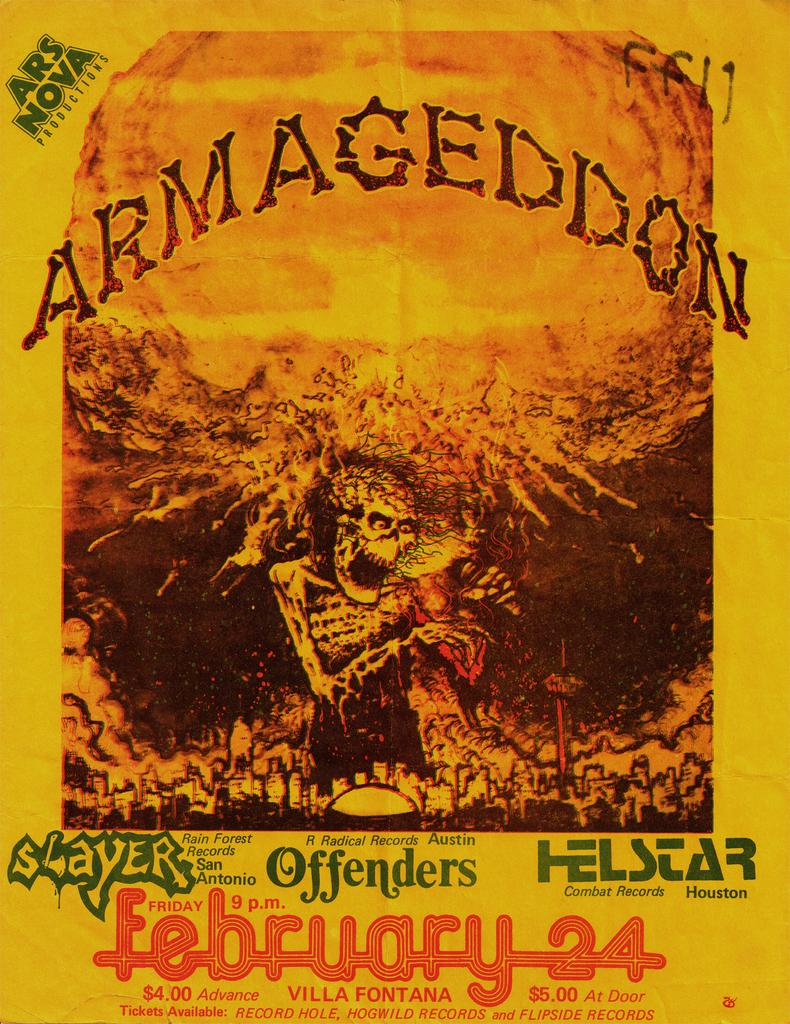<image>
Create a compact narrative representing the image presented. a poster with the words Armageddon and a skeleton on the front. 